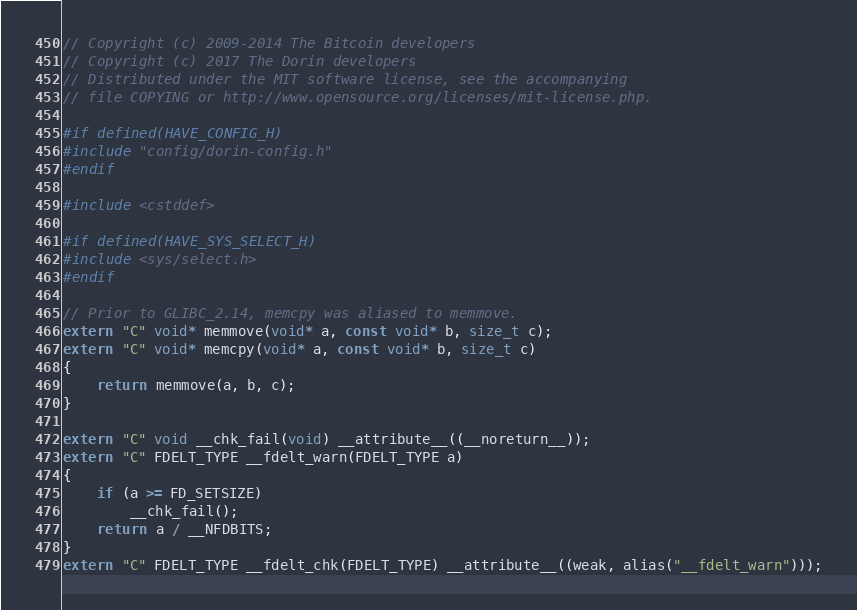<code> <loc_0><loc_0><loc_500><loc_500><_C++_>// Copyright (c) 2009-2014 The Bitcoin developers
// Copyright (c) 2017 The Dorin developers
// Distributed under the MIT software license, see the accompanying
// file COPYING or http://www.opensource.org/licenses/mit-license.php.

#if defined(HAVE_CONFIG_H)
#include "config/dorin-config.h"
#endif

#include <cstddef>

#if defined(HAVE_SYS_SELECT_H)
#include <sys/select.h>
#endif

// Prior to GLIBC_2.14, memcpy was aliased to memmove.
extern "C" void* memmove(void* a, const void* b, size_t c);
extern "C" void* memcpy(void* a, const void* b, size_t c)
{
    return memmove(a, b, c);
}

extern "C" void __chk_fail(void) __attribute__((__noreturn__));
extern "C" FDELT_TYPE __fdelt_warn(FDELT_TYPE a)
{
    if (a >= FD_SETSIZE)
        __chk_fail();
    return a / __NFDBITS;
}
extern "C" FDELT_TYPE __fdelt_chk(FDELT_TYPE) __attribute__((weak, alias("__fdelt_warn")));
</code> 